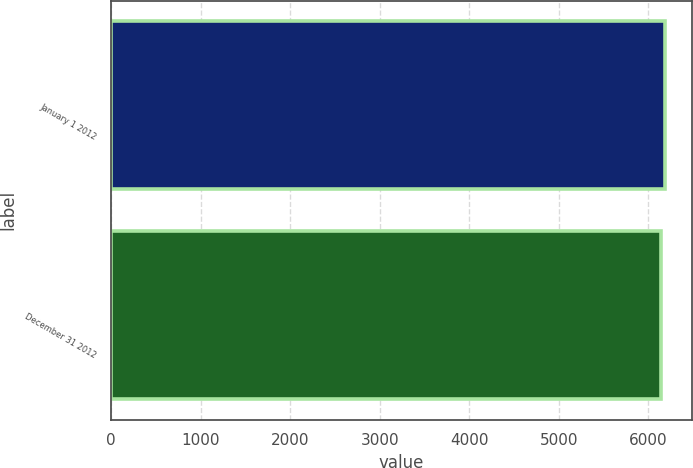Convert chart to OTSL. <chart><loc_0><loc_0><loc_500><loc_500><bar_chart><fcel>January 1 2012<fcel>December 31 2012<nl><fcel>6180.6<fcel>6141<nl></chart> 